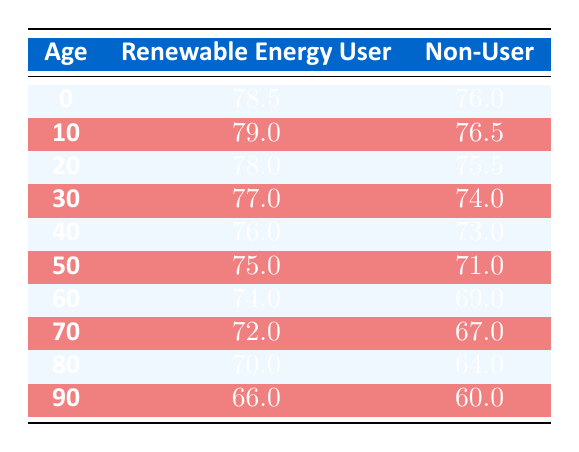What is the life expectancy for renewable energy users at age 0? According to the table, the life expectancy for renewable energy users at age 0 is 78.5.
Answer: 78.5 What is the difference in life expectancy between renewable energy users and non-users at age 40? At age 40, renewable energy users have a life expectancy of 76.0, while non-users have 73.0. The difference is 76.0 - 73.0 = 3.0.
Answer: 3.0 Are renewable energy users expected to live longer than non-users at age 90? At age 90, renewable energy users live for 66.0 years, while non-users live for 60.0 years. Since 66.0 is greater than 60.0, the answer is yes.
Answer: Yes What is the average life expectancy of non-users across all age groups provided? To find the average for non-users, sum all their life expectancies: 76.0 + 76.5 + 75.5 + 74.0 + 73.0 + 71.0 + 69.0 + 67.0 + 64.0 + 60.0 =  746.0 and since there are 10 age groups, the average is 746.0 / 10 = 74.6.
Answer: 74.6 At what age do renewable energy users start having a life expectancy below 75 years? Looking at the data, renewable energy users fall below 75 years starting from age 50 where their expectancy is 75.0 and drops to 74.0 at age 60.
Answer: 50 What is the comparative life expectancy for renewable energy users at age 70 and non-users at age 60? The life expectancy for renewable energy users at age 70 is 72.0 years and for non-users at age 60 is 69.0 years. Therefore, renewable energy users at age 70 live 3 years longer than non-users at age 60.
Answer: 3 years longer Is the life expectancy for renewable energy users at age 20 higher than the life expectancy for non-users at age 10? Renewable energy users at age 20 have a life expectancy of 78.0, while non-users at age 10 have 76.5. Since 78.0 is greater than 76.5, the answer is yes.
Answer: Yes What is the life expectancy increase for renewable energy users from age 60 to age 10? The life expectancy for renewable energy users at age 10 is 79.0 and at age 60 is 74.0. The increase is calculated as 79.0 - 74.0 = 5.0 years.
Answer: 5.0 years 